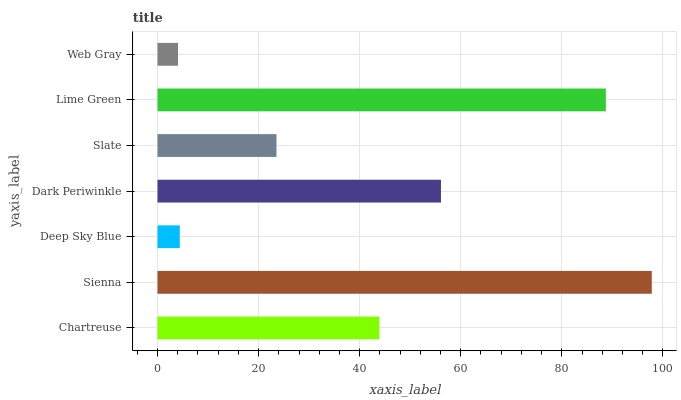Is Web Gray the minimum?
Answer yes or no. Yes. Is Sienna the maximum?
Answer yes or no. Yes. Is Deep Sky Blue the minimum?
Answer yes or no. No. Is Deep Sky Blue the maximum?
Answer yes or no. No. Is Sienna greater than Deep Sky Blue?
Answer yes or no. Yes. Is Deep Sky Blue less than Sienna?
Answer yes or no. Yes. Is Deep Sky Blue greater than Sienna?
Answer yes or no. No. Is Sienna less than Deep Sky Blue?
Answer yes or no. No. Is Chartreuse the high median?
Answer yes or no. Yes. Is Chartreuse the low median?
Answer yes or no. Yes. Is Web Gray the high median?
Answer yes or no. No. Is Dark Periwinkle the low median?
Answer yes or no. No. 